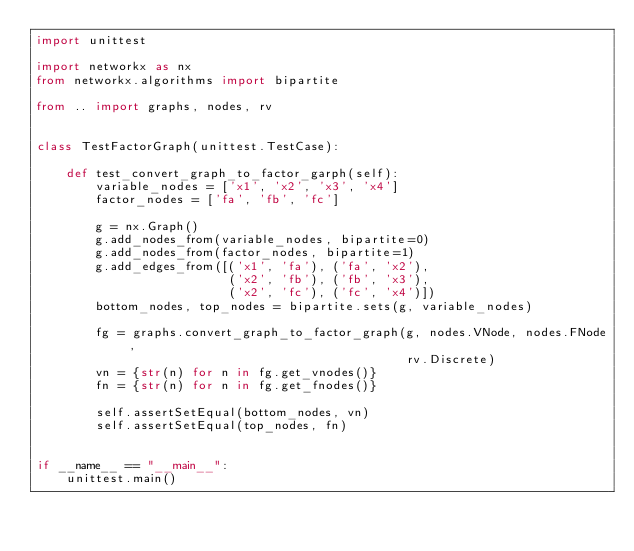Convert code to text. <code><loc_0><loc_0><loc_500><loc_500><_Python_>import unittest

import networkx as nx
from networkx.algorithms import bipartite

from .. import graphs, nodes, rv


class TestFactorGraph(unittest.TestCase):

    def test_convert_graph_to_factor_garph(self):
        variable_nodes = ['x1', 'x2', 'x3', 'x4']
        factor_nodes = ['fa', 'fb', 'fc']

        g = nx.Graph()
        g.add_nodes_from(variable_nodes, bipartite=0)
        g.add_nodes_from(factor_nodes, bipartite=1)
        g.add_edges_from([('x1', 'fa'), ('fa', 'x2'),
                          ('x2', 'fb'), ('fb', 'x3'),
                          ('x2', 'fc'), ('fc', 'x4')])
        bottom_nodes, top_nodes = bipartite.sets(g, variable_nodes)

        fg = graphs.convert_graph_to_factor_graph(g, nodes.VNode, nodes.FNode,
                                                  rv.Discrete)
        vn = {str(n) for n in fg.get_vnodes()}
        fn = {str(n) for n in fg.get_fnodes()}

        self.assertSetEqual(bottom_nodes, vn)
        self.assertSetEqual(top_nodes, fn)


if __name__ == "__main__":
    unittest.main()
</code> 